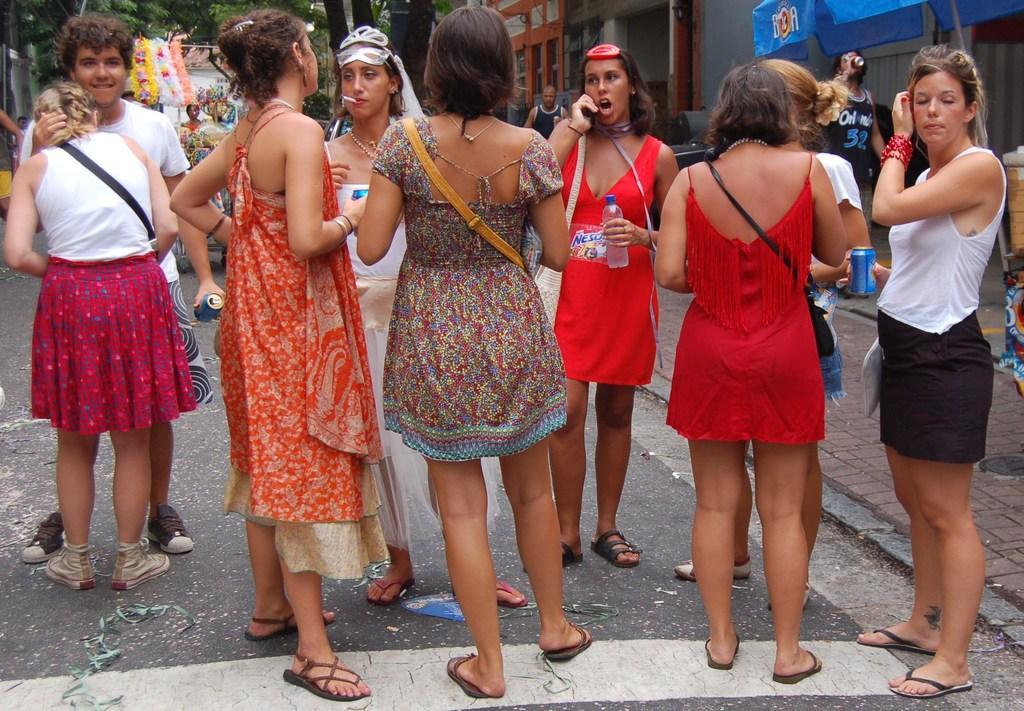Can you describe this image briefly? There is a group of women standing as we can see in the middle of this image. We can see trees and buildings in the background. 